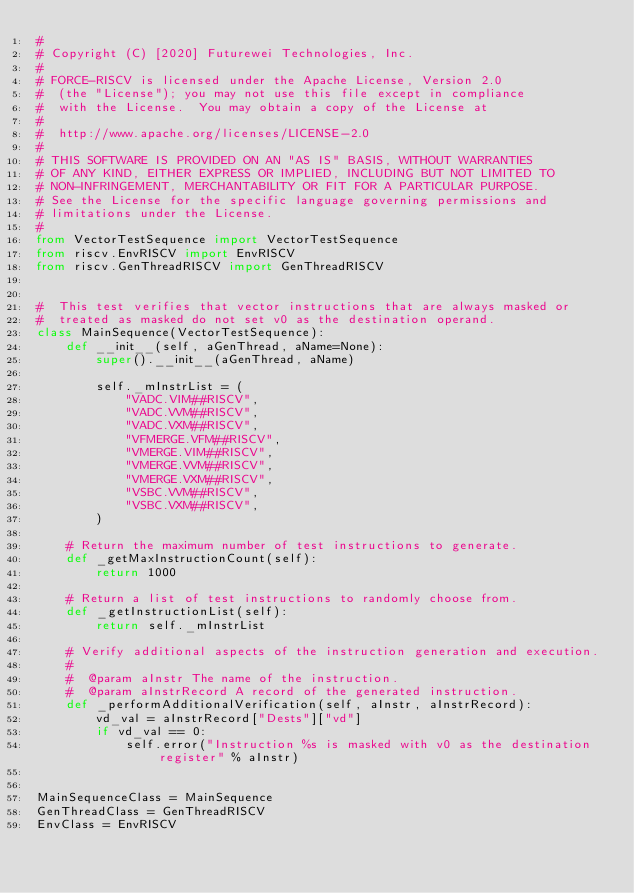<code> <loc_0><loc_0><loc_500><loc_500><_Python_>#
# Copyright (C) [2020] Futurewei Technologies, Inc.
#
# FORCE-RISCV is licensed under the Apache License, Version 2.0
#  (the "License"); you may not use this file except in compliance
#  with the License.  You may obtain a copy of the License at
#
#  http://www.apache.org/licenses/LICENSE-2.0
#
# THIS SOFTWARE IS PROVIDED ON AN "AS IS" BASIS, WITHOUT WARRANTIES
# OF ANY KIND, EITHER EXPRESS OR IMPLIED, INCLUDING BUT NOT LIMITED TO
# NON-INFRINGEMENT, MERCHANTABILITY OR FIT FOR A PARTICULAR PURPOSE.
# See the License for the specific language governing permissions and
# limitations under the License.
#
from VectorTestSequence import VectorTestSequence
from riscv.EnvRISCV import EnvRISCV
from riscv.GenThreadRISCV import GenThreadRISCV


#  This test verifies that vector instructions that are always masked or
#  treated as masked do not set v0 as the destination operand.
class MainSequence(VectorTestSequence):
    def __init__(self, aGenThread, aName=None):
        super().__init__(aGenThread, aName)

        self._mInstrList = (
            "VADC.VIM##RISCV",
            "VADC.VVM##RISCV",
            "VADC.VXM##RISCV",
            "VFMERGE.VFM##RISCV",
            "VMERGE.VIM##RISCV",
            "VMERGE.VVM##RISCV",
            "VMERGE.VXM##RISCV",
            "VSBC.VVM##RISCV",
            "VSBC.VXM##RISCV",
        )

    # Return the maximum number of test instructions to generate.
    def _getMaxInstructionCount(self):
        return 1000

    # Return a list of test instructions to randomly choose from.
    def _getInstructionList(self):
        return self._mInstrList

    # Verify additional aspects of the instruction generation and execution.
    #
    #  @param aInstr The name of the instruction.
    #  @param aInstrRecord A record of the generated instruction.
    def _performAdditionalVerification(self, aInstr, aInstrRecord):
        vd_val = aInstrRecord["Dests"]["vd"]
        if vd_val == 0:
            self.error("Instruction %s is masked with v0 as the destination register" % aInstr)


MainSequenceClass = MainSequence
GenThreadClass = GenThreadRISCV
EnvClass = EnvRISCV
</code> 